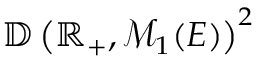Convert formula to latex. <formula><loc_0><loc_0><loc_500><loc_500>\mathbb { D } \left ( \mathbb { R } _ { + } , \mathcal { M } _ { 1 } ( E ) \right ) ^ { 2 }</formula> 